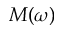<formula> <loc_0><loc_0><loc_500><loc_500>M ( \omega )</formula> 